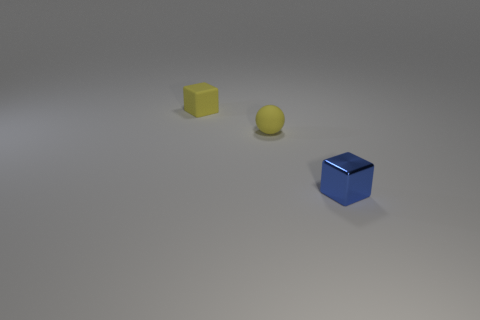Add 2 tiny matte things. How many objects exist? 5 Subtract all balls. How many objects are left? 2 Subtract all green cylinders. How many yellow cubes are left? 1 Subtract all yellow matte cubes. Subtract all blue things. How many objects are left? 1 Add 1 tiny yellow rubber blocks. How many tiny yellow rubber blocks are left? 2 Add 3 green objects. How many green objects exist? 3 Subtract 0 blue cylinders. How many objects are left? 3 Subtract all green balls. Subtract all gray cylinders. How many balls are left? 1 